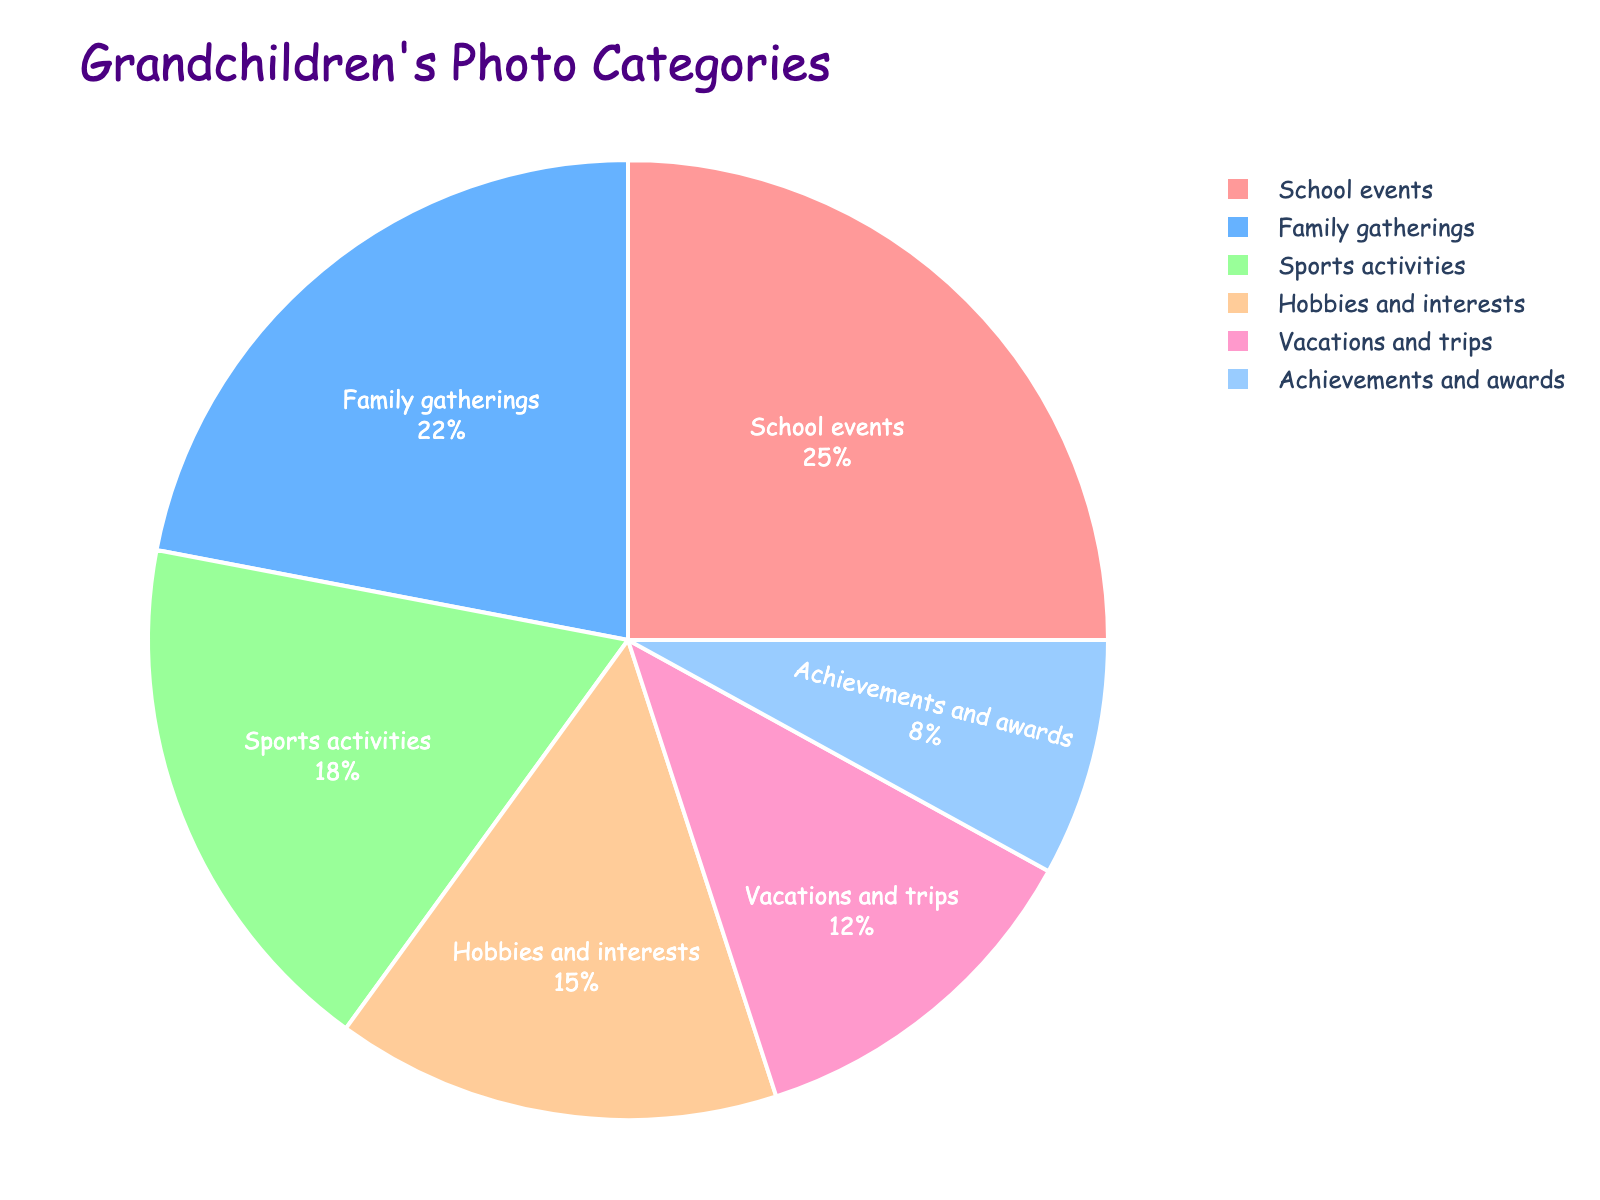Which category occupies 25% of the photo shares? The pie chart shows that the "School events" category takes up 25% of the total photo shares, as indicated by the percentage label inside the section corresponding to this category.
Answer: School events Which category has the smallest share? The pie chart displays percentages next to each category's name. The smallest percentage is 8%, which corresponds to the "Achievements and awards" category.
Answer: Achievements and awards What is the combined percentage of photos from "Family gatherings" and "Vacations and trips"? To find the combined percentage, sum the percentages for "Family gatherings" (22%) and "Vacations and trips" (12%): 22% + 12% = 34%.
Answer: 34% How does the percentage of "Sports activities" photos compare to "Hobbies and interests"? By looking at the pie chart, "Sports activities" covers 18% while "Hobbies and interests" covers 15%. Therefore, "Sports activities" has a higher percentage than "Hobbies and interests".
Answer: Sports activities is higher Which category is represented with the color blue? From the pie chart, "Sports activities" is represented with the color blue, identifiable by its corresponding color segment in the chart.
Answer: Sports activities What percentage of photos are related to events or gatherings? Summing "School events" (25%) and "Family gatherings" (22%) results in 25% + 22% = 47%.
Answer: 47% Is there more emphasis on achievements or leisure activities? Comparing "Achievements and awards" (8%) to the sum of "Sports activities" (18%) and "Hobbies and interests" (15%), which equals 33%, shows that leisure activities are emphasized more.
Answer: Leisure activities Which portion of the pie chart is pink? Observing the pie chart, the pink portion corresponds to "School events".
Answer: School events What is the difference in percentage between "Sports activities" and "Achievements and awards"? Subtracting the percentage of "Achievements and awards" (8%) from "Sports activities" (18%): 18% - 8% = 10%.
Answer: 10% 